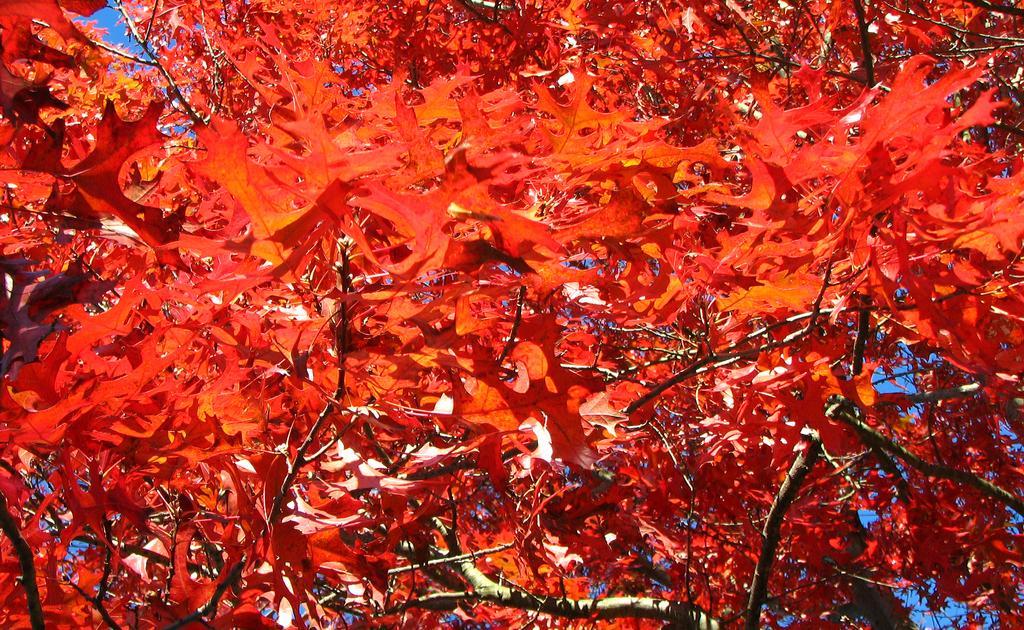In one or two sentences, can you explain what this image depicts? In this picture there are many red color leaves on the tree. 